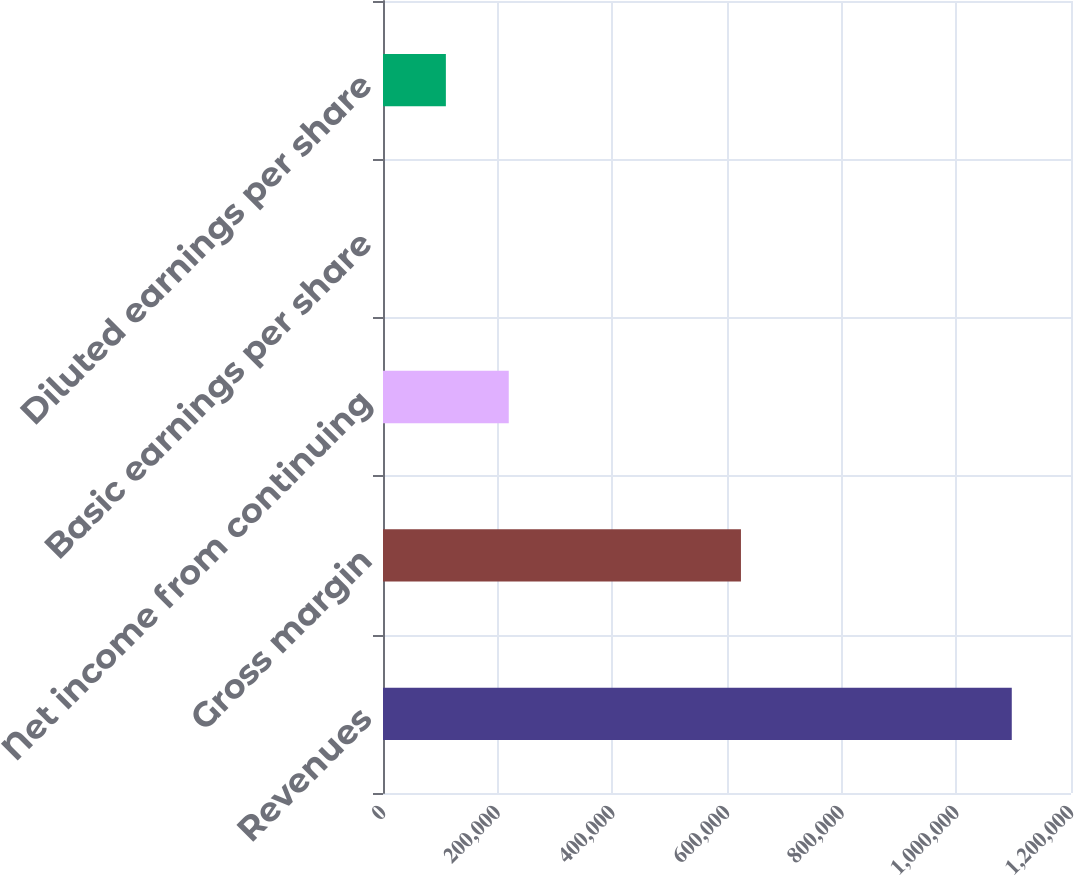Convert chart. <chart><loc_0><loc_0><loc_500><loc_500><bar_chart><fcel>Revenues<fcel>Gross margin<fcel>Net income from continuing<fcel>Basic earnings per share<fcel>Diluted earnings per share<nl><fcel>1.0967e+06<fcel>624328<fcel>219342<fcel>1.71<fcel>109672<nl></chart> 